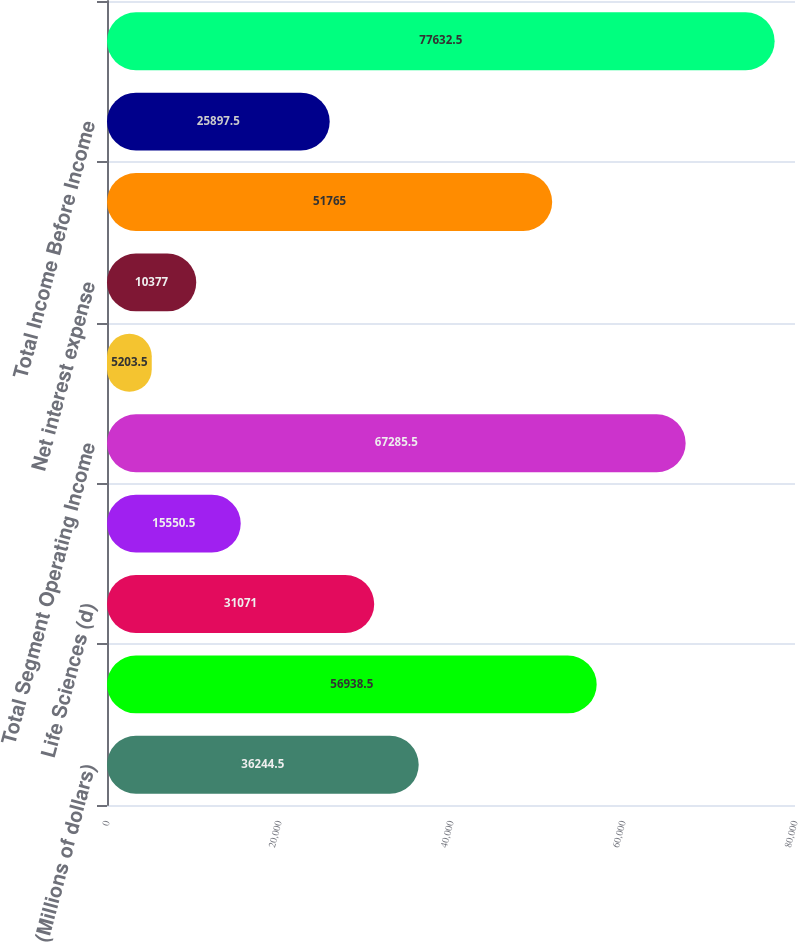Convert chart to OTSL. <chart><loc_0><loc_0><loc_500><loc_500><bar_chart><fcel>(Millions of dollars)<fcel>Medical (a) (b) (c)<fcel>Life Sciences (d)<fcel>Interventional (b) (e) (f)<fcel>Total Segment Operating Income<fcel>Acquisitions and other<fcel>Net interest expense<fcel>Other unallocated items (g)<fcel>Total Income Before Income<fcel>Medical<nl><fcel>36244.5<fcel>56938.5<fcel>31071<fcel>15550.5<fcel>67285.5<fcel>5203.5<fcel>10377<fcel>51765<fcel>25897.5<fcel>77632.5<nl></chart> 